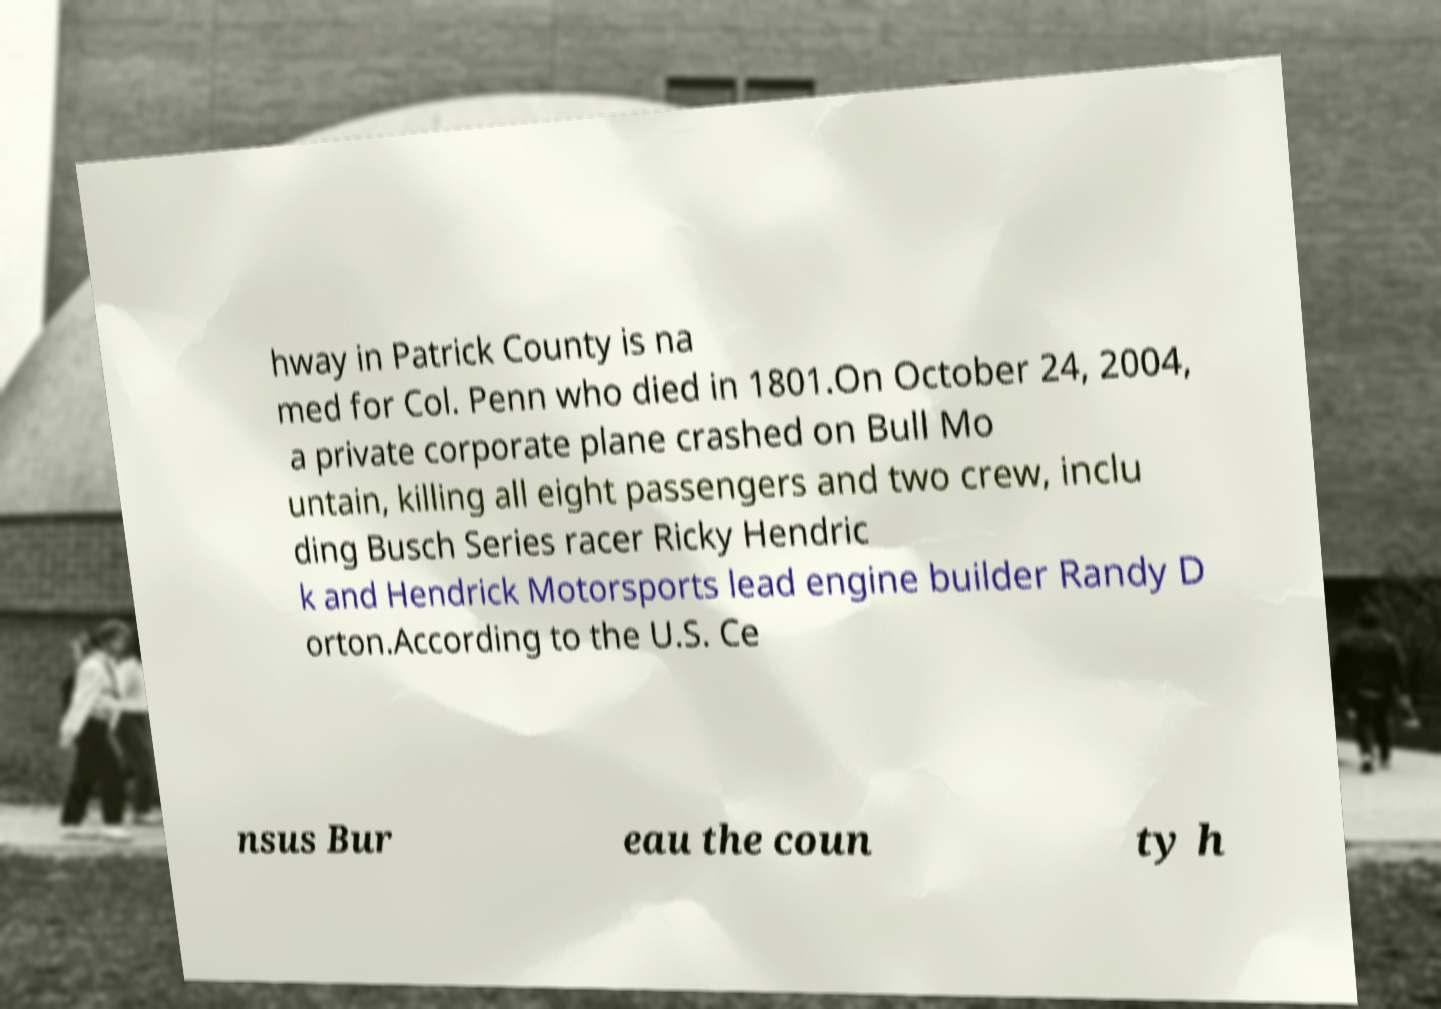Can you accurately transcribe the text from the provided image for me? hway in Patrick County is na med for Col. Penn who died in 1801.On October 24, 2004, a private corporate plane crashed on Bull Mo untain, killing all eight passengers and two crew, inclu ding Busch Series racer Ricky Hendric k and Hendrick Motorsports lead engine builder Randy D orton.According to the U.S. Ce nsus Bur eau the coun ty h 